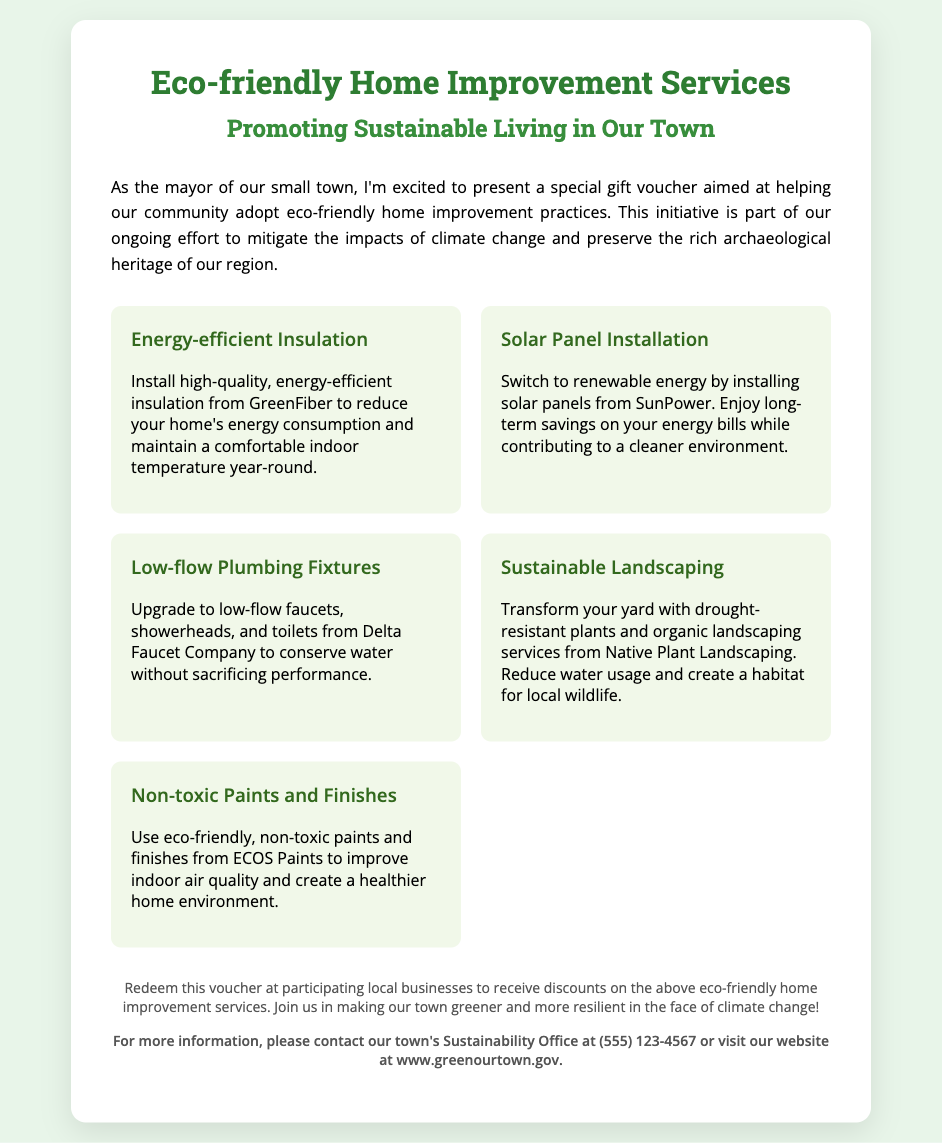What is the title of the voucher? The title of the voucher is prominently displayed at the top of the document.
Answer: Eco-friendly Home Improvement Services What service helps maintain indoor temperature? This service is described in the context of energy efficiency and insulation.
Answer: Energy-efficient Insulation Which company offers solar panels? The company name is mentioned in relation to renewable energy solutions in the document.
Answer: SunPower What type of fixtures are mentioned for conserving water? The text specifies the kind of fixtures used to save water in home improvements.
Answer: Low-flow Plumbing Fixtures What is the contact number for the Sustainability Office? The contact number is provided for obtaining further information about the voucher.
Answer: (555) 123-4567 How many eco-friendly services are listed? The total count is derived from the services section of the voucher.
Answer: Five What is the purpose of the voucher? The purpose is stated in the introduction of the document, outlining its goal.
Answer: Help the community adopt eco-friendly home improvement practices What type of paint is recommended for better air quality? The document specifies the type of paint that improves indoor air quality.
Answer: Non-toxic Paints and Finishes What is the primary theme of the voucher? The main theme is reflected in the introductory paragraph.
Answer: Sustainable Living 